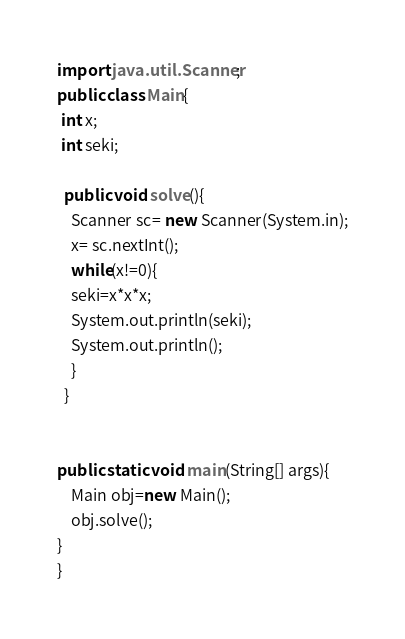<code> <loc_0><loc_0><loc_500><loc_500><_Java_>import java.util.Scanner;
public class Main{
 int x;
 int seki;
  
  public void solve(){
    Scanner sc= new Scanner(System.in);
    x= sc.nextInt();
    while(x!=0){
    seki=x*x*x;
    System.out.println(seki);
    System.out.println();
    }
  }


public static void main(String[] args){
    Main obj=new Main();
    obj.solve();
}
}</code> 